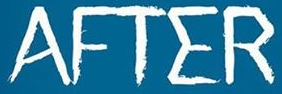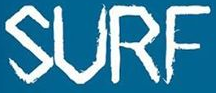Read the text content from these images in order, separated by a semicolon. AFTER; SURF 